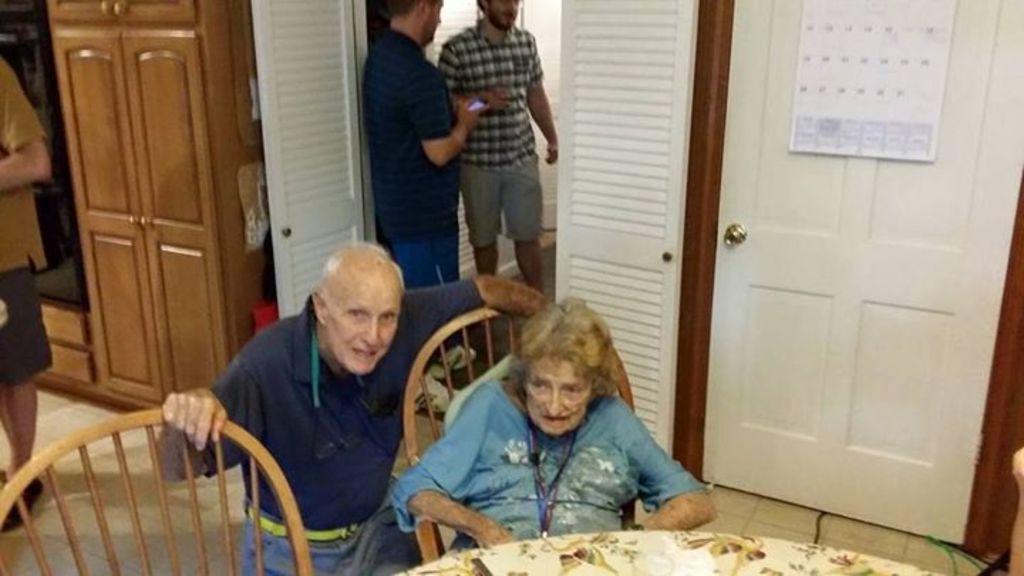Can you describe this image briefly? In this image i can see a woman and a man sitting at the the back ground i can see two other Man standing, a door, a calendar at left i can see i can see the other persons standing. 